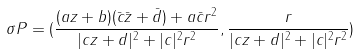<formula> <loc_0><loc_0><loc_500><loc_500>\sigma P = ( \frac { ( a z + b ) ( \bar { c } \bar { z } + \bar { d } ) + a \bar { c } r ^ { 2 } } { | c z + d | ^ { 2 } + | c | ^ { 2 } r ^ { 2 } } , \frac { r } { | c z + d | ^ { 2 } + | c | ^ { 2 } r ^ { 2 } } )</formula> 